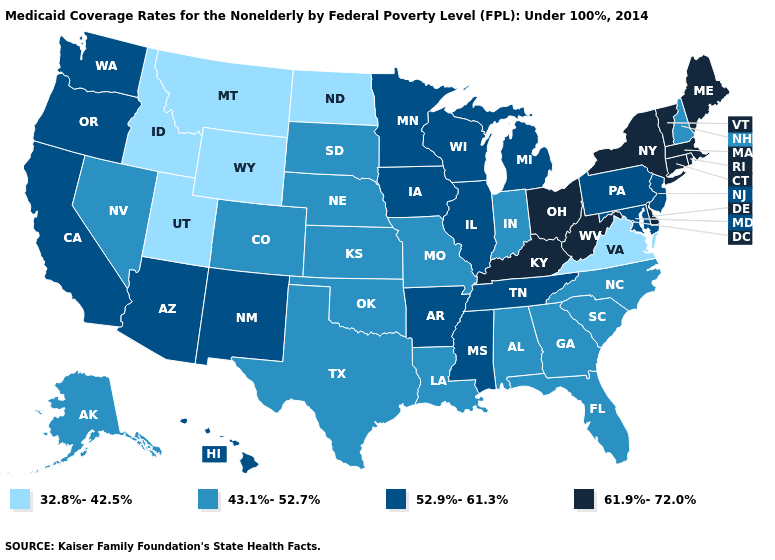Which states have the lowest value in the USA?
Answer briefly. Idaho, Montana, North Dakota, Utah, Virginia, Wyoming. Among the states that border Mississippi , which have the highest value?
Give a very brief answer. Arkansas, Tennessee. Name the states that have a value in the range 52.9%-61.3%?
Give a very brief answer. Arizona, Arkansas, California, Hawaii, Illinois, Iowa, Maryland, Michigan, Minnesota, Mississippi, New Jersey, New Mexico, Oregon, Pennsylvania, Tennessee, Washington, Wisconsin. Does Louisiana have the highest value in the USA?
Answer briefly. No. What is the value of New Hampshire?
Be succinct. 43.1%-52.7%. What is the lowest value in the West?
Concise answer only. 32.8%-42.5%. Is the legend a continuous bar?
Concise answer only. No. What is the value of Arizona?
Short answer required. 52.9%-61.3%. Name the states that have a value in the range 61.9%-72.0%?
Answer briefly. Connecticut, Delaware, Kentucky, Maine, Massachusetts, New York, Ohio, Rhode Island, Vermont, West Virginia. What is the lowest value in the Northeast?
Short answer required. 43.1%-52.7%. Does the first symbol in the legend represent the smallest category?
Answer briefly. Yes. What is the lowest value in the South?
Concise answer only. 32.8%-42.5%. What is the value of Utah?
Write a very short answer. 32.8%-42.5%. Does Connecticut have the lowest value in the USA?
Answer briefly. No. Name the states that have a value in the range 43.1%-52.7%?
Give a very brief answer. Alabama, Alaska, Colorado, Florida, Georgia, Indiana, Kansas, Louisiana, Missouri, Nebraska, Nevada, New Hampshire, North Carolina, Oklahoma, South Carolina, South Dakota, Texas. 